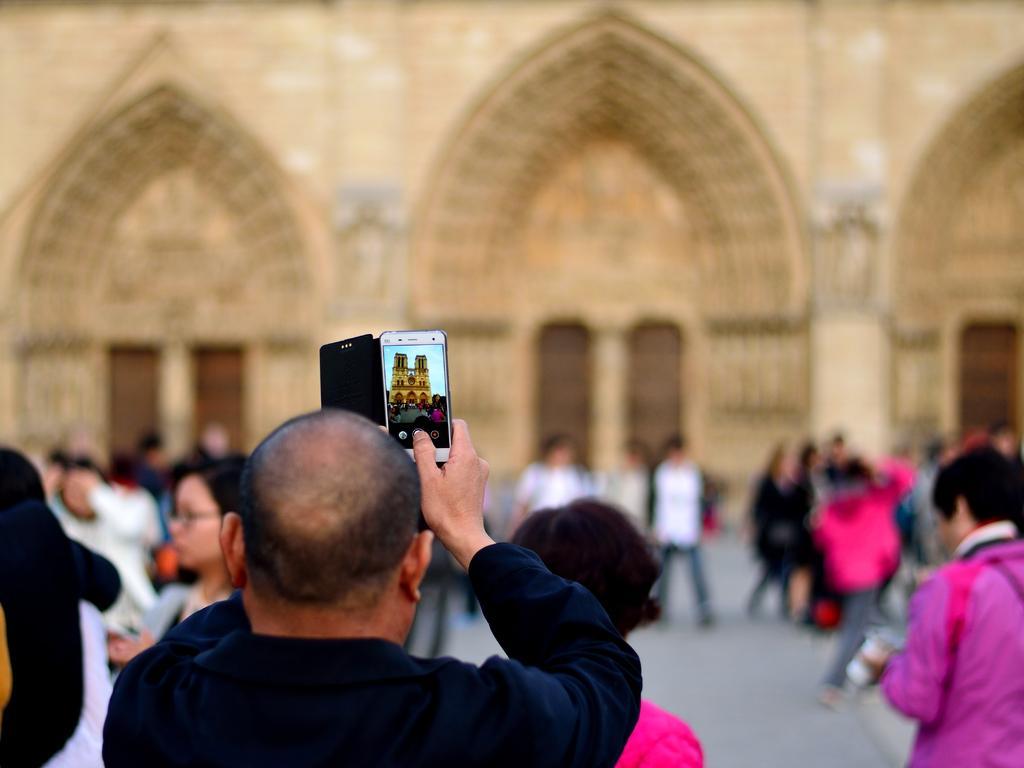Please provide a concise description of this image. In this image, we can see a person is holding a mobile. Here we can see screen. In this screen, we can see for, few people, path and sky. In the background of the image, we can see blur view. Here there are few people and walls. 